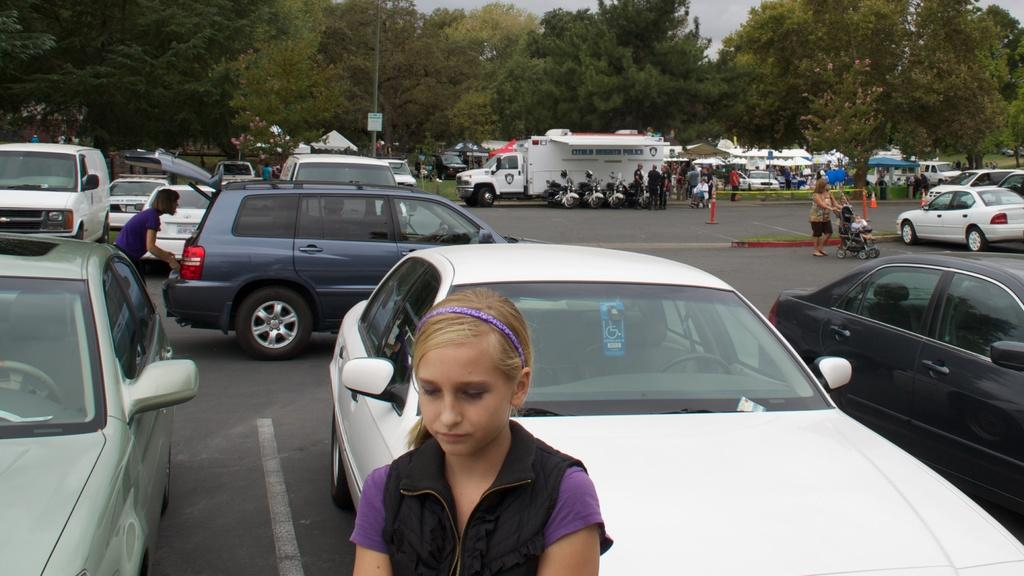Who is the main subject in the image? There is a girl in the center of the image. What can be seen in the background of the image? In the background, there are cars, persons, bikes, a truck, tents, trees, a pole, and the sky. Can you describe the vehicles in the background? There are cars, bikes, and a truck visible in the background. What type of structures are present in the background? There are tents and a pole visible in the background. What is visible in the sky in the image? The sky is visible in the background of the image. What type of thunder can be heard in the image? There is no thunder present in the image, as it is a still photograph. What offer is being made by the girl in the image? There is no indication of an offer being made in the image; the girl is simply standing in the center. 